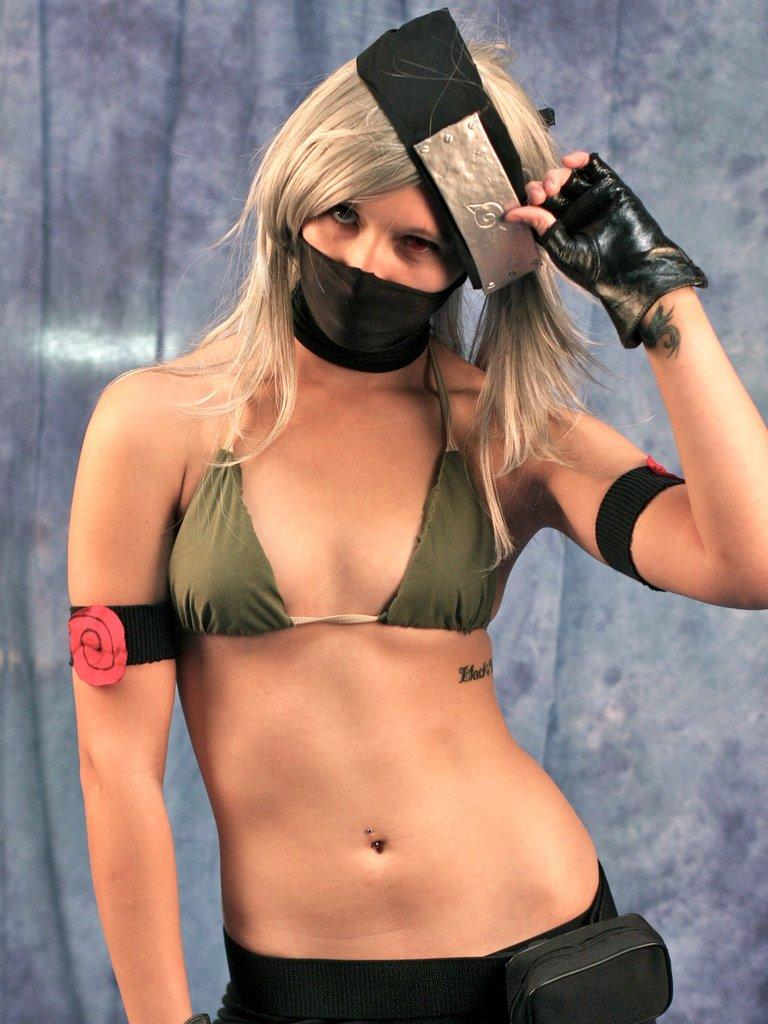What is the main subject of the image? There is a woman standing in the image. What is the woman doing in the image? The woman is holding an object in her hand near her head. What can be seen in the background of the image? There is a wall in the background of the image. What type of chin is visible on the woman in the image? There is no chin visible on the woman in the image, as the image only shows her from the neck up. --- Facts: 1. There is a car in the image. 2. The car is parked on the street. 3. There are trees in the background of the image. 4. The sky is visible in the image. Absurd Topics: parrot, sand, bicycle Conversation: What is the main subject of the image? There is a car in the image. Where is the car located in the image? The car is parked on the street. What can be seen in the background of the image? There are trees in the background of the image. What is visible above the trees in the image? The sky is visible in the image. Reasoning: Let's think step by step in order to produce the conversation. We start by identifying the main subject of the image, which is the car. Then, we describe the location of the car, which is parked on the street. Next, we mention the background of the image, which includes trees. Finally, we acknowledge the presence of the sky above the trees. Absurd Question/Answer: Can you tell me how many parrots are sitting on the car in the image? There are no parrots present in the image; it only features a car parked on the street. Is there a bicycle leaning against the car in the image? There is no bicycle present in the image; it only features a car parked on the street. 